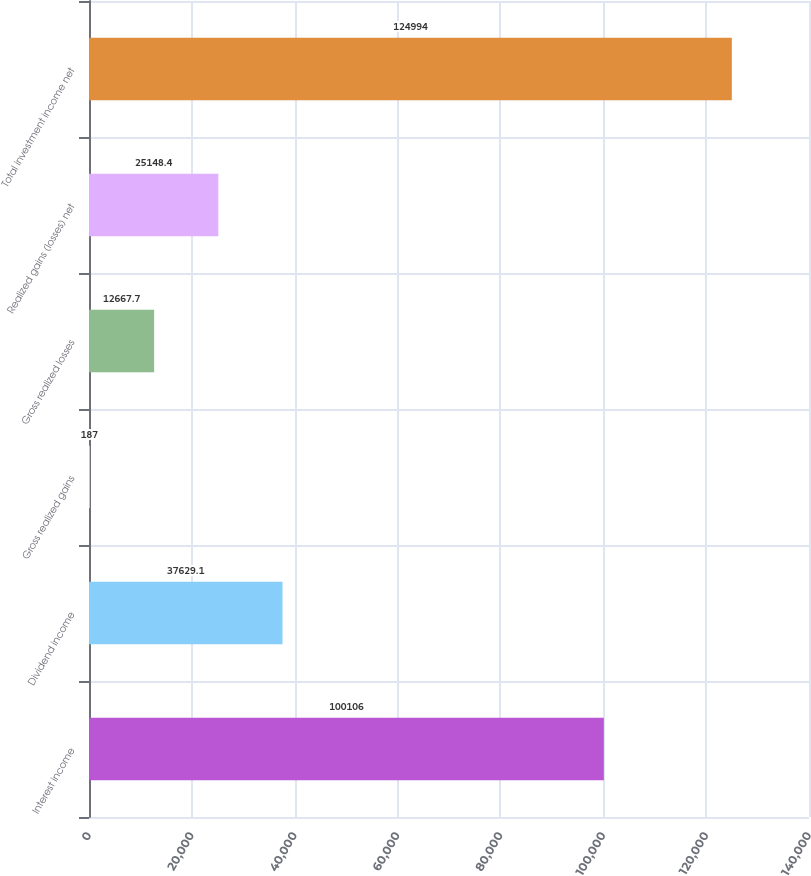Convert chart to OTSL. <chart><loc_0><loc_0><loc_500><loc_500><bar_chart><fcel>Interest income<fcel>Dividend income<fcel>Gross realized gains<fcel>Gross realized losses<fcel>Realized gains (losses) net<fcel>Total investment income net<nl><fcel>100106<fcel>37629.1<fcel>187<fcel>12667.7<fcel>25148.4<fcel>124994<nl></chart> 